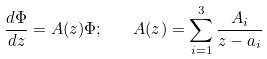<formula> <loc_0><loc_0><loc_500><loc_500>\frac { d \Phi } { d z } = A ( z ) \Phi ; \quad A ( z ) = \sum _ { i = 1 } ^ { 3 } \frac { A _ { i } } { z - a _ { i } }</formula> 